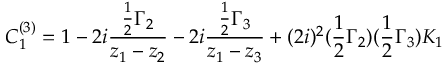Convert formula to latex. <formula><loc_0><loc_0><loc_500><loc_500>C _ { 1 } ^ { ( 3 ) } = 1 - 2 i { \frac { { \frac { 1 } { 2 } } \Gamma _ { 2 } } { z _ { 1 } - z _ { 2 } } } - 2 i { \frac { { \frac { 1 } { 2 } } \Gamma _ { 3 } } { z _ { 1 } - z _ { 3 } } } + ( 2 i ) ^ { 2 } ( { \frac { 1 } { 2 } } \Gamma _ { 2 } ) ( { \frac { 1 } { 2 } } \Gamma _ { 3 } ) K _ { 1 }</formula> 